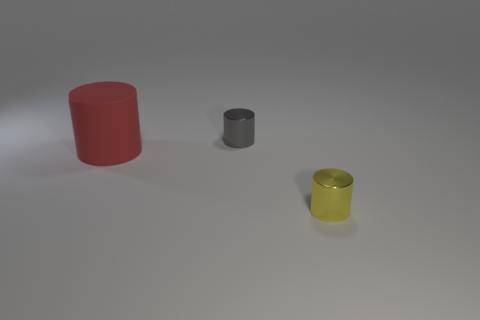Subtract all tiny cylinders. How many cylinders are left? 1 Subtract 1 cylinders. How many cylinders are left? 2 Add 1 tiny yellow shiny cylinders. How many objects exist? 4 Subtract all gray cylinders. How many cylinders are left? 2 Subtract all gray balls. How many blue cylinders are left? 0 Subtract all red cylinders. Subtract all cyan cubes. How many cylinders are left? 2 Subtract 1 red cylinders. How many objects are left? 2 Subtract all small gray metal objects. Subtract all small gray metallic objects. How many objects are left? 1 Add 3 tiny objects. How many tiny objects are left? 5 Add 1 red things. How many red things exist? 2 